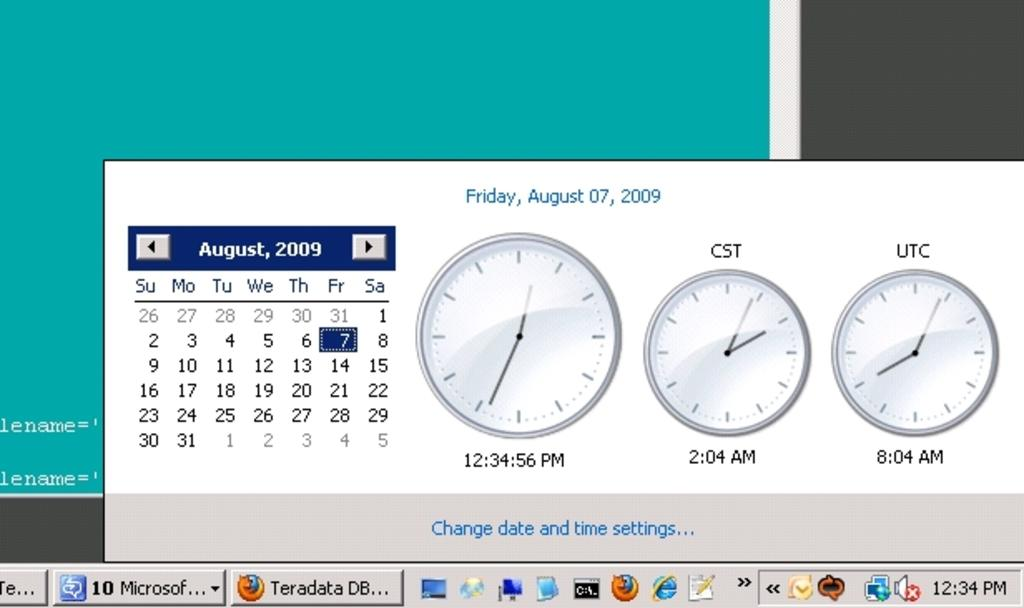<image>
Give a short and clear explanation of the subsequent image. The calender and time setting tab on a computer screen with August 7th, Firday at 12:34:56 pm on it. 